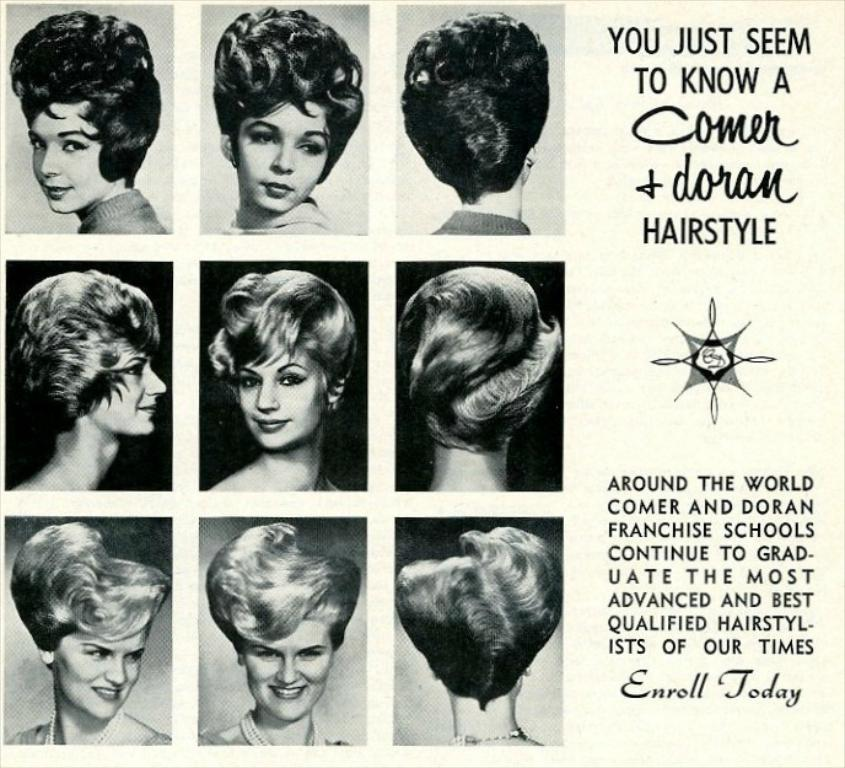What is the main subject in the center of the image? There is a paper in the center of the image. What can be seen on the paper? There are human faces on the paper, and they are smiling. Is there any text on the paper? Yes, there is writing on the paper. Can you tell me how many planes are waiting at the airport in the image? There is no airport or planes present in the image; it features a paper with smiling human faces and writing. Is there a beggar asking for money in the image? There is no beggar present in the image; it features a paper with smiling human faces and writing. 